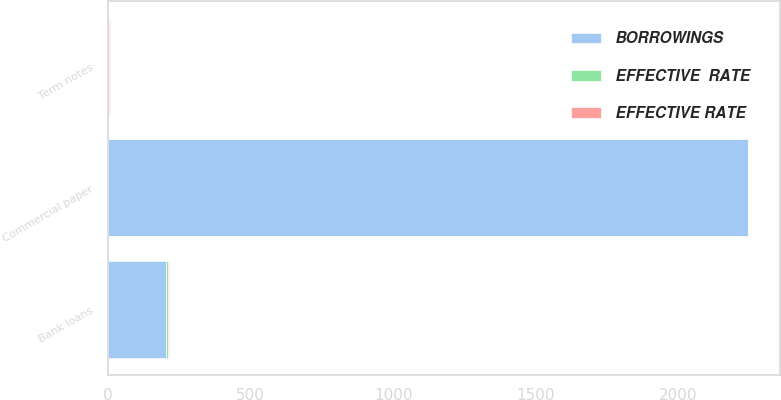Convert chart. <chart><loc_0><loc_0><loc_500><loc_500><stacked_bar_chart><ecel><fcel>Commercial paper<fcel>Bank loans<fcel>Term notes<nl><fcel>EFFECTIVE RATE<fcel>0.7<fcel>5.5<fcel>1.5<nl><fcel>BORROWINGS<fcel>2242.5<fcel>205<fcel>3.15<nl><fcel>EFFECTIVE  RATE<fcel>0.6<fcel>4.8<fcel>1.4<nl></chart> 